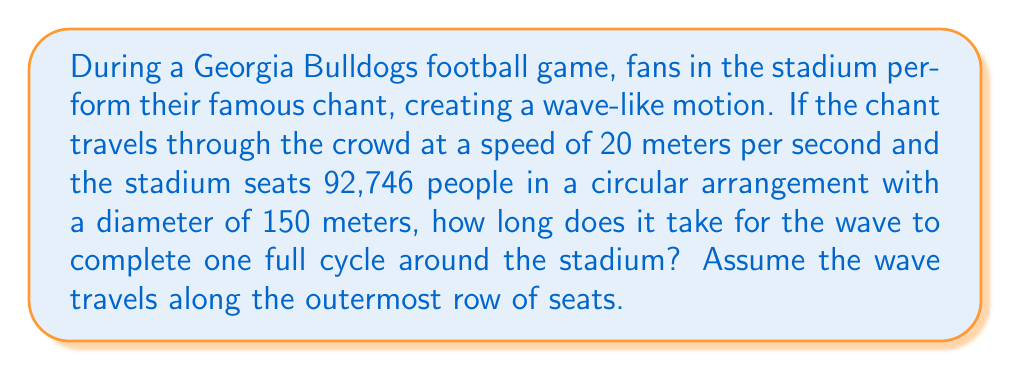What is the answer to this math problem? To solve this problem, we need to follow these steps:

1. Calculate the circumference of the stadium:
   The stadium is circular with a diameter of 150 meters.
   Circumference = $\pi d$, where $d$ is the diameter.
   $C = \pi \times 150 \text{ m} = 471.24 \text{ m}$

2. Use the wave speed equation:
   $v = \frac{d}{t}$, where $v$ is velocity, $d$ is distance, and $t$ is time.

3. Rearrange the equation to solve for time:
   $t = \frac{d}{v}$

4. Substitute the known values:
   $t = \frac{471.24 \text{ m}}{20 \text{ m/s}}$

5. Calculate the result:
   $t = 23.562 \text{ seconds}$

Therefore, it takes approximately 23.56 seconds for the wave to complete one full cycle around the stadium.
Answer: 23.56 seconds 